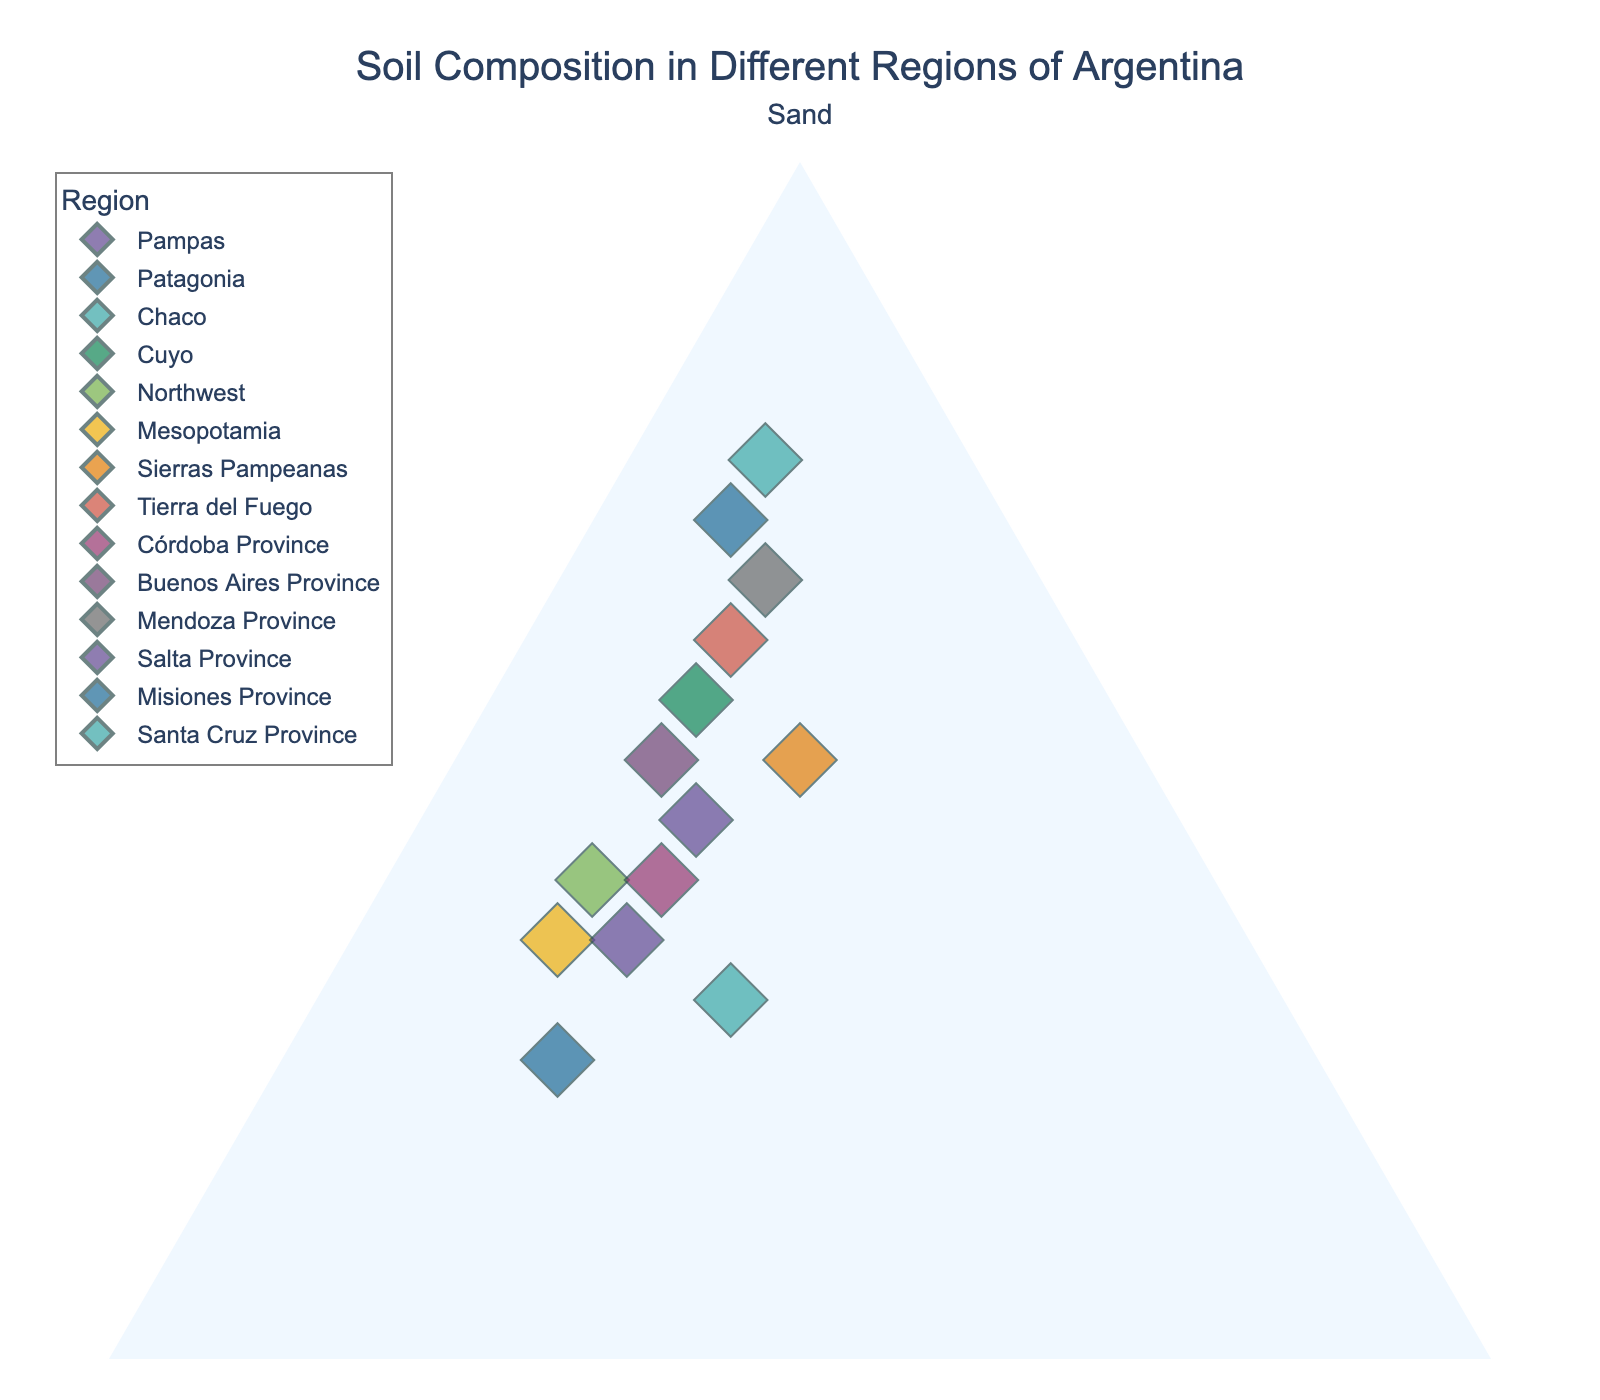What is the title of the plot? The title is located at the top center of the plot in bold. In this case, it clearly states "Soil Composition in Different Regions of Argentina."
Answer: Soil Composition in Different Regions of Argentina How many regions are displayed in the plot? By observing the number of distinct points or markers in the plot, each representing a different region, we can count them to determine the total number of regions.
Answer: 14 Which region has the highest percentage of sand? Look for the point furthest along the 'Sand' axis, representing the highest percentage of sand. In this plot, the furthest point along the sand axis corresponds to Santa Cruz Province.
Answer: Santa Cruz Province Which region has the highest percentage of clay? Identify the point that extends the furthest along the 'Clay' axis. This point represents the region with the highest clay percentage. Chaco has the highest clay value.
Answer: Chaco What is the total percentage of sand, silt, and clay for Córdoba Province? Add the percentages of sand, silt, and clay for Córdoba Province: Sand (40) + Silt (40) + Clay (20) = 100%.
Answer: 100% Compare the percentage of silt between Pampas and Mesopotamia. Which region has more silt? Observe the position of Pampas and Mesopotamia along the 'Silt' axis. The region that extends further towards the silt direction has a greater percentage. Mesopotamia has 50% silt, higher than Pampas with 35%.
Answer: Mesopotamia Which region is closest to having an equal composition of sand, silt, and clay? Look for the point nearest to the center of the ternary plot, which indicates more balanced proportions of all three components. Chaco (30% sand, 40% silt, 30% clay) is the closest to an equal composition.
Answer: Chaco How many regions have more than 50% sand? Count the number of points located beyond the 50% mark along the 'Sand' axis. Regions: Patagonia, Cuyo, Tierra del Fuego, Mendoza Province, Santa Cruz Province.
Answer: 5 Which region has the most balanced composition of silt and clay? Identify the regions where the percentages of silt and clay are closest to each other. In this case, Sierras Pampeanas (25% silt, 25% clay) has the most balanced composition.
Answer: Sierras Pampeanas 